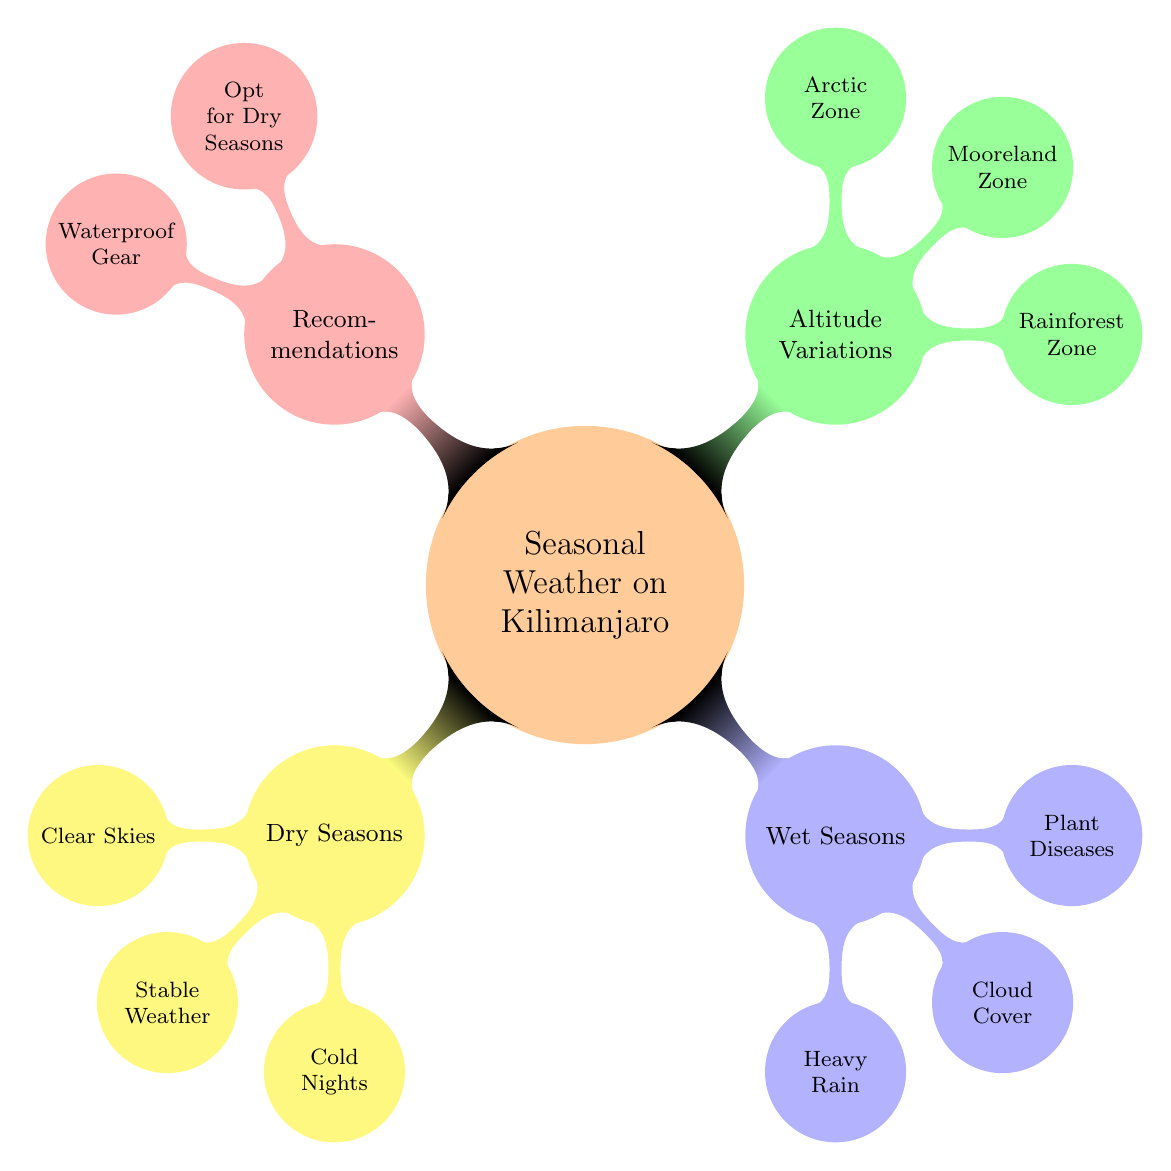What are the two dry seasons? The diagram states that the dry seasons are from January to mid-March and from June to October. This information is directly provided under the "Dry Seasons" node in the mind map.
Answer: January to mid-March, June to October What is a challenge in the Rainforest Zone? The diagram highlights the challenges faced in the Rainforest Zone as "Humidity, Muddy Trails." This information is found under the "Base (Rainforest Zone)" node in the "Altitude Variations" section.
Answer: Humidity, Muddy Trails What is the weather in the Arctic Zone? According to the "High Altitude (Arctic Zone)" node, the weather is described as "Cold and Dry." This is the listed weather condition for that specific altitude in the mind map.
Answer: Cold and Dry What should climbers invest in for the wet seasons? The "Recommendations" section clearly indicates that climbers should invest in "Waterproof Gear for Wet Seasons." This information is provided under the "Gear Tips" node.
Answer: Waterproof Gear What impact does cloud cover have during wet seasons? The diagram states under "Wet Seasons" that "Cloud Cover" results in "Obscured Views, Reduced Visibility." Thus, this is the direct consequence of cloud cover during that time.
Answer: Obscured Views, Reduced Visibility What is the best timing for climbing Mount Kilimanjaro? The "Recommendations" node specifies that the best timing for climbing is to "Opt for Dry Seasons." This is clearly stated and readily accessible in the mind map.
Answer: Opt for Dry Seasons How many main sections are in the mind map? The diagram contains four main sections: "Dry Seasons," "Wet Seasons," "Altitude Variations," and "Recommendations." By counting the child nodes of the main concept, the answer can be directly determined.
Answer: Four What is one impact of heavy rain during wet seasons? The diagram indicates under "Wet Seasons" that heavy rain leads to "Slippery Trails, Increased Risk of Landslides." Thus, this is one of the identified impacts of heavy rain.
Answer: Slippery Trails, Increased Risk of Landslides 